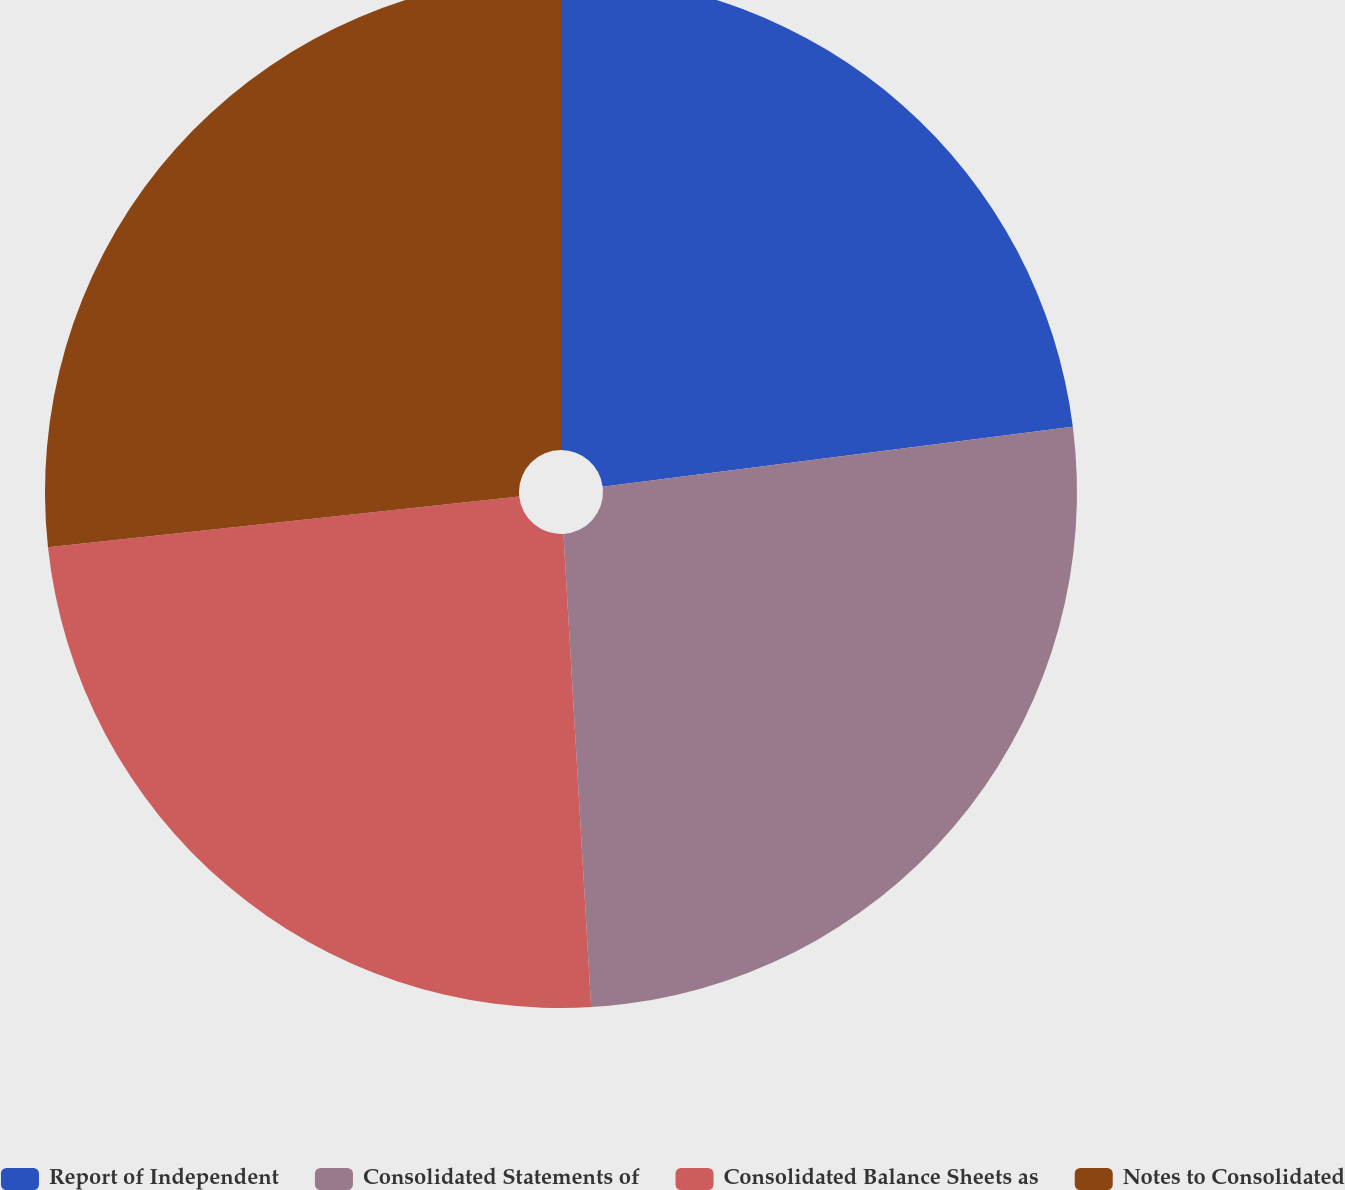<chart> <loc_0><loc_0><loc_500><loc_500><pie_chart><fcel>Report of Independent<fcel>Consolidated Statements of<fcel>Consolidated Balance Sheets as<fcel>Notes to Consolidated<nl><fcel>22.98%<fcel>26.09%<fcel>24.22%<fcel>26.71%<nl></chart> 